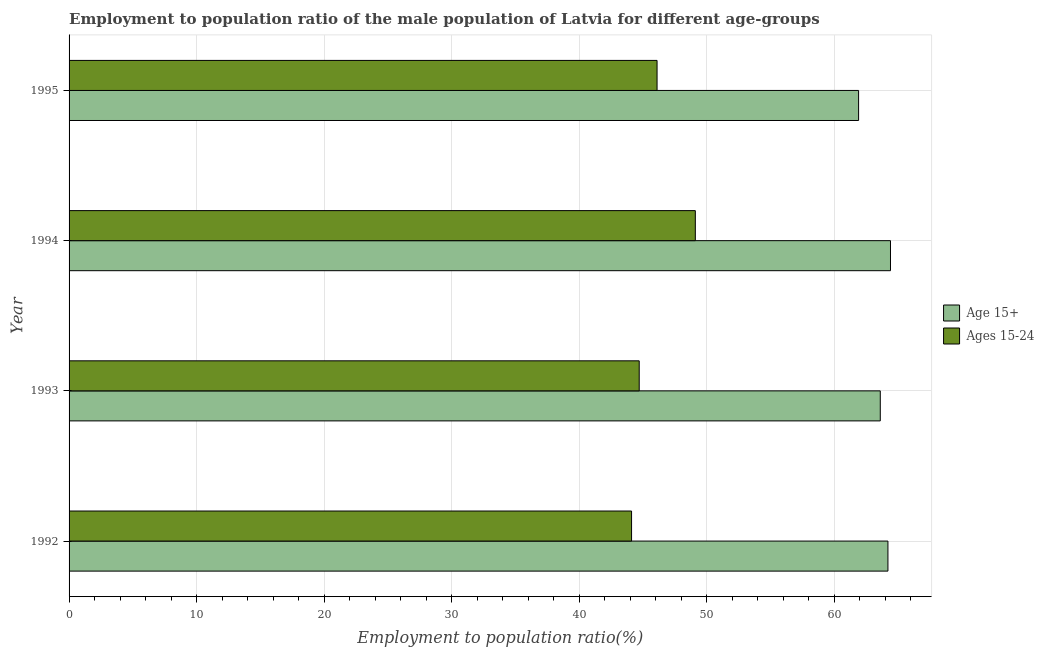How many groups of bars are there?
Your response must be concise. 4. What is the employment to population ratio(age 15-24) in 1993?
Make the answer very short. 44.7. Across all years, what is the maximum employment to population ratio(age 15+)?
Offer a terse response. 64.4. Across all years, what is the minimum employment to population ratio(age 15+)?
Make the answer very short. 61.9. In which year was the employment to population ratio(age 15+) maximum?
Give a very brief answer. 1994. What is the total employment to population ratio(age 15+) in the graph?
Offer a terse response. 254.1. What is the difference between the employment to population ratio(age 15+) in 1994 and the employment to population ratio(age 15-24) in 1993?
Ensure brevity in your answer.  19.7. In the year 1994, what is the difference between the employment to population ratio(age 15-24) and employment to population ratio(age 15+)?
Ensure brevity in your answer.  -15.3. In how many years, is the employment to population ratio(age 15-24) greater than 38 %?
Offer a terse response. 4. What is the ratio of the employment to population ratio(age 15-24) in 1992 to that in 1995?
Offer a terse response. 0.96. Is the employment to population ratio(age 15-24) in 1992 less than that in 1993?
Your response must be concise. Yes. What is the difference between the highest and the second highest employment to population ratio(age 15+)?
Your response must be concise. 0.2. What is the difference between the highest and the lowest employment to population ratio(age 15+)?
Give a very brief answer. 2.5. In how many years, is the employment to population ratio(age 15-24) greater than the average employment to population ratio(age 15-24) taken over all years?
Give a very brief answer. 2. What does the 2nd bar from the top in 1993 represents?
Your answer should be compact. Age 15+. What does the 2nd bar from the bottom in 1995 represents?
Your answer should be compact. Ages 15-24. What is the difference between two consecutive major ticks on the X-axis?
Provide a short and direct response. 10. Does the graph contain any zero values?
Keep it short and to the point. No. Does the graph contain grids?
Your response must be concise. Yes. How are the legend labels stacked?
Ensure brevity in your answer.  Vertical. What is the title of the graph?
Offer a very short reply. Employment to population ratio of the male population of Latvia for different age-groups. Does "Not attending school" appear as one of the legend labels in the graph?
Your answer should be compact. No. What is the label or title of the X-axis?
Give a very brief answer. Employment to population ratio(%). What is the Employment to population ratio(%) of Age 15+ in 1992?
Your answer should be compact. 64.2. What is the Employment to population ratio(%) of Ages 15-24 in 1992?
Give a very brief answer. 44.1. What is the Employment to population ratio(%) of Age 15+ in 1993?
Your answer should be very brief. 63.6. What is the Employment to population ratio(%) in Ages 15-24 in 1993?
Your answer should be very brief. 44.7. What is the Employment to population ratio(%) in Age 15+ in 1994?
Make the answer very short. 64.4. What is the Employment to population ratio(%) in Ages 15-24 in 1994?
Keep it short and to the point. 49.1. What is the Employment to population ratio(%) of Age 15+ in 1995?
Your response must be concise. 61.9. What is the Employment to population ratio(%) in Ages 15-24 in 1995?
Ensure brevity in your answer.  46.1. Across all years, what is the maximum Employment to population ratio(%) of Age 15+?
Offer a terse response. 64.4. Across all years, what is the maximum Employment to population ratio(%) in Ages 15-24?
Provide a succinct answer. 49.1. Across all years, what is the minimum Employment to population ratio(%) of Age 15+?
Provide a succinct answer. 61.9. Across all years, what is the minimum Employment to population ratio(%) in Ages 15-24?
Provide a short and direct response. 44.1. What is the total Employment to population ratio(%) in Age 15+ in the graph?
Provide a succinct answer. 254.1. What is the total Employment to population ratio(%) in Ages 15-24 in the graph?
Offer a terse response. 184. What is the difference between the Employment to population ratio(%) in Age 15+ in 1992 and that in 1993?
Your response must be concise. 0.6. What is the difference between the Employment to population ratio(%) of Ages 15-24 in 1992 and that in 1993?
Make the answer very short. -0.6. What is the difference between the Employment to population ratio(%) in Ages 15-24 in 1992 and that in 1994?
Your answer should be very brief. -5. What is the difference between the Employment to population ratio(%) of Age 15+ in 1992 and that in 1995?
Make the answer very short. 2.3. What is the difference between the Employment to population ratio(%) of Ages 15-24 in 1994 and that in 1995?
Offer a terse response. 3. What is the difference between the Employment to population ratio(%) of Age 15+ in 1992 and the Employment to population ratio(%) of Ages 15-24 in 1993?
Your answer should be compact. 19.5. What is the difference between the Employment to population ratio(%) of Age 15+ in 1992 and the Employment to population ratio(%) of Ages 15-24 in 1994?
Make the answer very short. 15.1. What is the difference between the Employment to population ratio(%) in Age 15+ in 1992 and the Employment to population ratio(%) in Ages 15-24 in 1995?
Offer a very short reply. 18.1. What is the difference between the Employment to population ratio(%) in Age 15+ in 1993 and the Employment to population ratio(%) in Ages 15-24 in 1994?
Ensure brevity in your answer.  14.5. What is the difference between the Employment to population ratio(%) of Age 15+ in 1993 and the Employment to population ratio(%) of Ages 15-24 in 1995?
Your response must be concise. 17.5. What is the difference between the Employment to population ratio(%) of Age 15+ in 1994 and the Employment to population ratio(%) of Ages 15-24 in 1995?
Provide a succinct answer. 18.3. What is the average Employment to population ratio(%) in Age 15+ per year?
Your answer should be compact. 63.52. In the year 1992, what is the difference between the Employment to population ratio(%) of Age 15+ and Employment to population ratio(%) of Ages 15-24?
Your answer should be very brief. 20.1. In the year 1993, what is the difference between the Employment to population ratio(%) in Age 15+ and Employment to population ratio(%) in Ages 15-24?
Offer a very short reply. 18.9. In the year 1995, what is the difference between the Employment to population ratio(%) in Age 15+ and Employment to population ratio(%) in Ages 15-24?
Give a very brief answer. 15.8. What is the ratio of the Employment to population ratio(%) of Age 15+ in 1992 to that in 1993?
Provide a short and direct response. 1.01. What is the ratio of the Employment to population ratio(%) of Ages 15-24 in 1992 to that in 1993?
Your response must be concise. 0.99. What is the ratio of the Employment to population ratio(%) of Age 15+ in 1992 to that in 1994?
Give a very brief answer. 1. What is the ratio of the Employment to population ratio(%) of Ages 15-24 in 1992 to that in 1994?
Offer a very short reply. 0.9. What is the ratio of the Employment to population ratio(%) in Age 15+ in 1992 to that in 1995?
Ensure brevity in your answer.  1.04. What is the ratio of the Employment to population ratio(%) of Ages 15-24 in 1992 to that in 1995?
Make the answer very short. 0.96. What is the ratio of the Employment to population ratio(%) of Age 15+ in 1993 to that in 1994?
Your answer should be compact. 0.99. What is the ratio of the Employment to population ratio(%) of Ages 15-24 in 1993 to that in 1994?
Ensure brevity in your answer.  0.91. What is the ratio of the Employment to population ratio(%) of Age 15+ in 1993 to that in 1995?
Your answer should be very brief. 1.03. What is the ratio of the Employment to population ratio(%) of Ages 15-24 in 1993 to that in 1995?
Your answer should be compact. 0.97. What is the ratio of the Employment to population ratio(%) of Age 15+ in 1994 to that in 1995?
Give a very brief answer. 1.04. What is the ratio of the Employment to population ratio(%) of Ages 15-24 in 1994 to that in 1995?
Keep it short and to the point. 1.07. What is the difference between the highest and the second highest Employment to population ratio(%) in Ages 15-24?
Provide a short and direct response. 3. What is the difference between the highest and the lowest Employment to population ratio(%) in Age 15+?
Offer a very short reply. 2.5. What is the difference between the highest and the lowest Employment to population ratio(%) in Ages 15-24?
Offer a terse response. 5. 